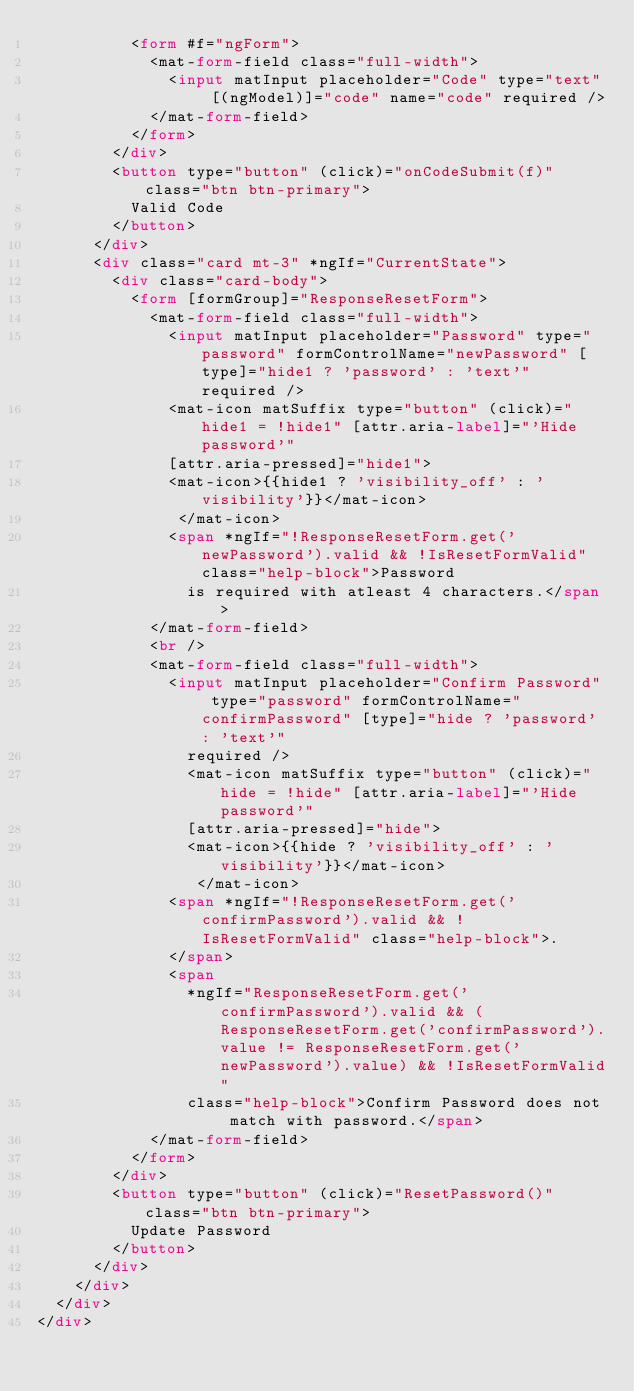<code> <loc_0><loc_0><loc_500><loc_500><_HTML_>          <form #f="ngForm">
            <mat-form-field class="full-width">
              <input matInput placeholder="Code" type="text" [(ngModel)]="code" name="code" required />
            </mat-form-field>
          </form>
        </div>
        <button type="button" (click)="onCodeSubmit(f)" class="btn btn-primary">
          Valid Code
        </button>
      </div>
      <div class="card mt-3" *ngIf="CurrentState">
        <div class="card-body">
          <form [formGroup]="ResponseResetForm">
            <mat-form-field class="full-width">
              <input matInput placeholder="Password" type="password" formControlName="newPassword" [type]="hide1 ? 'password' : 'text'" required />
              <mat-icon matSuffix type="button" (click)="hide1 = !hide1" [attr.aria-label]="'Hide password'"
              [attr.aria-pressed]="hide1">
              <mat-icon>{{hide1 ? 'visibility_off' : 'visibility'}}</mat-icon>
               </mat-icon>
              <span *ngIf="!ResponseResetForm.get('newPassword').valid && !IsResetFormValid" class="help-block">Password
                is required with atleast 4 characters.</span>
            </mat-form-field>
            <br />
            <mat-form-field class="full-width">
              <input matInput placeholder="Confirm Password" type="password" formControlName="confirmPassword" [type]="hide ? 'password' : 'text'"
                required />
                <mat-icon matSuffix type="button" (click)="hide = !hide" [attr.aria-label]="'Hide password'"
                [attr.aria-pressed]="hide">
                <mat-icon>{{hide ? 'visibility_off' : 'visibility'}}</mat-icon>
                 </mat-icon>
              <span *ngIf="!ResponseResetForm.get('confirmPassword').valid && !IsResetFormValid" class="help-block">.
              </span>
              <span
                *ngIf="ResponseResetForm.get('confirmPassword').valid && (ResponseResetForm.get('confirmPassword').value != ResponseResetForm.get('newPassword').value) && !IsResetFormValid"
                class="help-block">Confirm Password does not match with password.</span>
            </mat-form-field>
          </form>
        </div>
        <button type="button" (click)="ResetPassword()" class="btn btn-primary">
          Update Password
        </button>
      </div>
    </div>
  </div>
</div>
</code> 